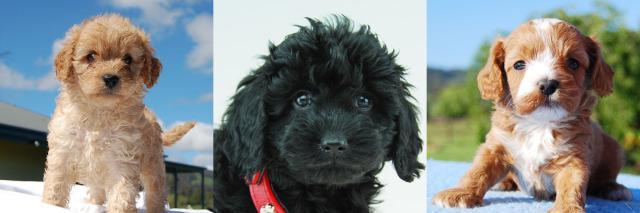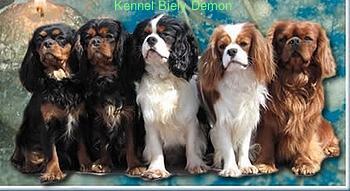The first image is the image on the left, the second image is the image on the right. Considering the images on both sides, is "Each image is a full body shot of four different dogs." valid? Answer yes or no. No. The first image is the image on the left, the second image is the image on the right. For the images displayed, is the sentence "Four dogs are outside together." factually correct? Answer yes or no. No. 